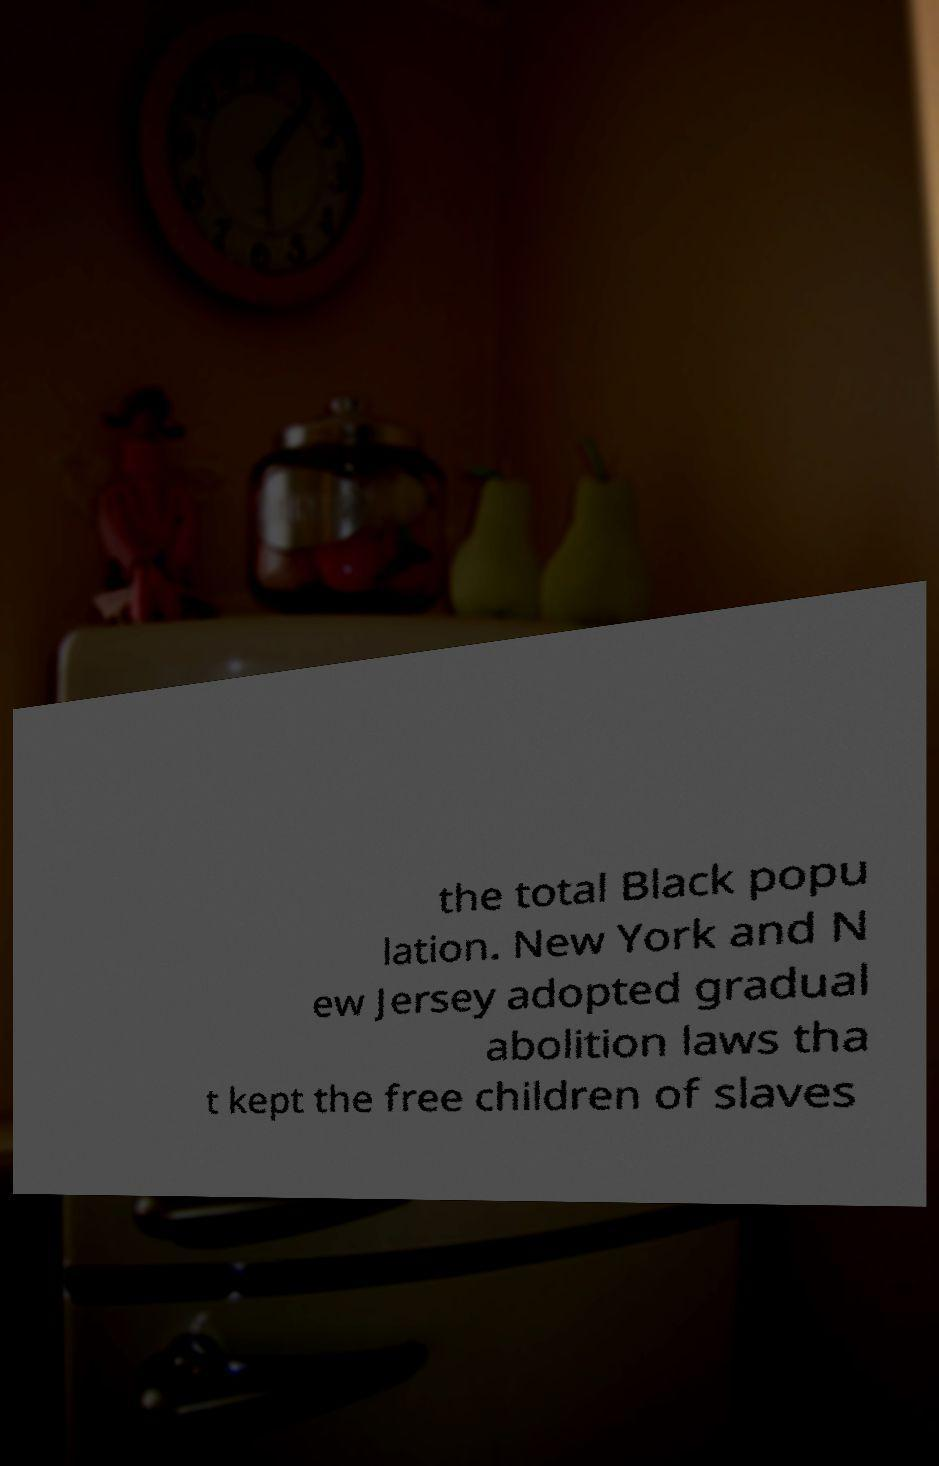For documentation purposes, I need the text within this image transcribed. Could you provide that? the total Black popu lation. New York and N ew Jersey adopted gradual abolition laws tha t kept the free children of slaves 